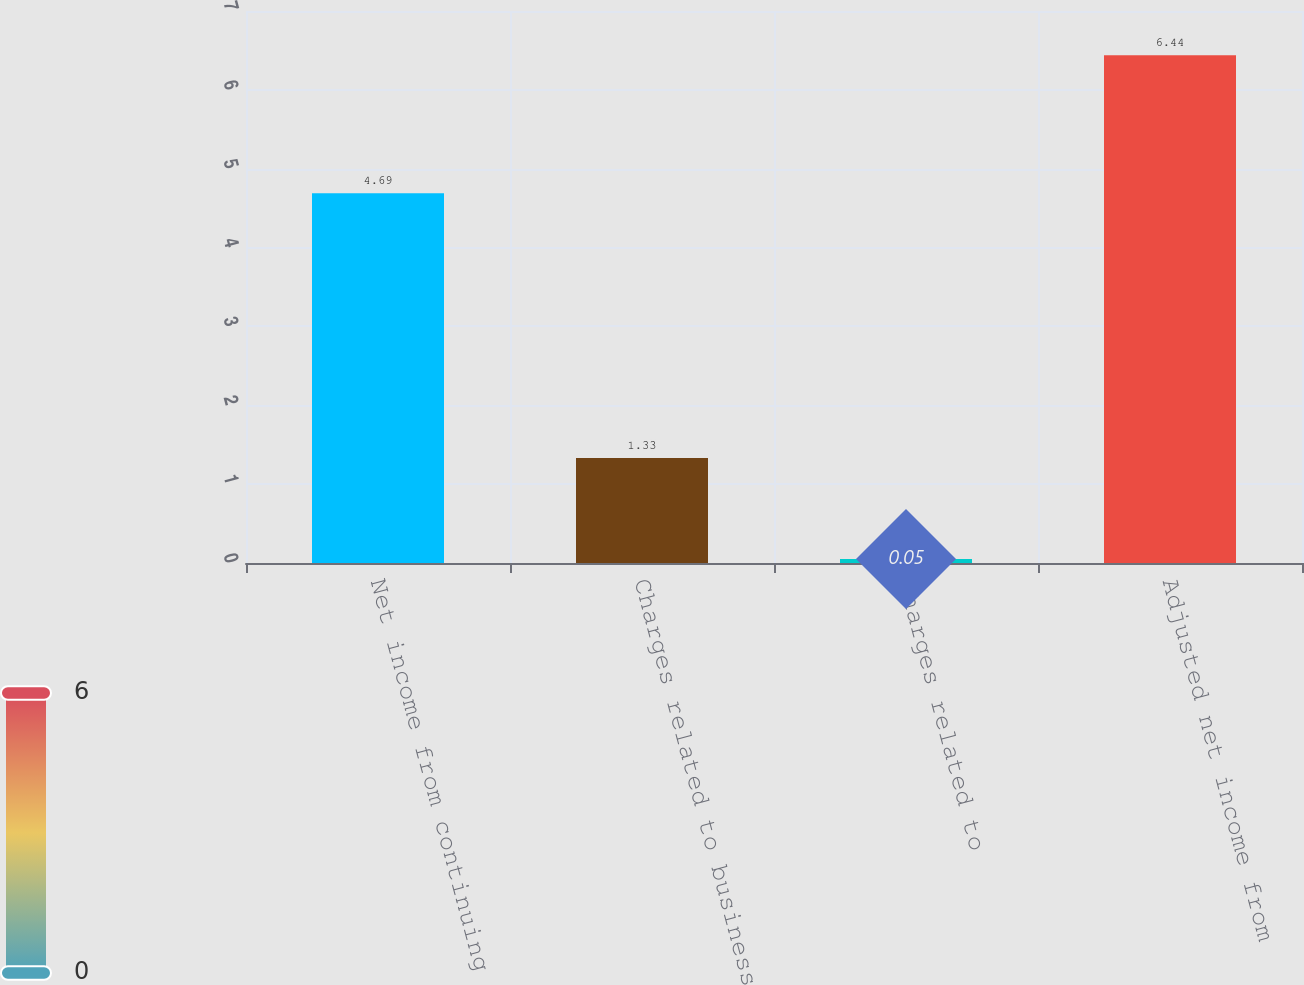<chart> <loc_0><loc_0><loc_500><loc_500><bar_chart><fcel>Net income from continuing<fcel>Charges related to business<fcel>Charges related to<fcel>Adjusted net income from<nl><fcel>4.69<fcel>1.33<fcel>0.05<fcel>6.44<nl></chart> 